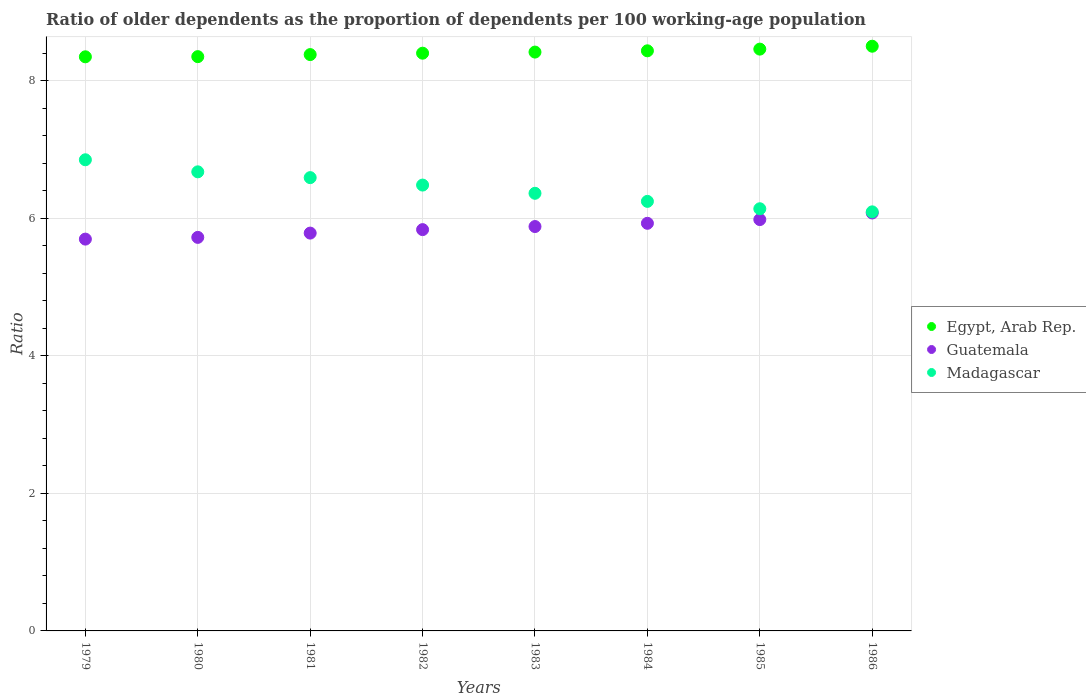How many different coloured dotlines are there?
Your answer should be very brief. 3. Is the number of dotlines equal to the number of legend labels?
Make the answer very short. Yes. What is the age dependency ratio(old) in Madagascar in 1984?
Ensure brevity in your answer.  6.24. Across all years, what is the maximum age dependency ratio(old) in Egypt, Arab Rep.?
Your answer should be compact. 8.5. Across all years, what is the minimum age dependency ratio(old) in Madagascar?
Offer a very short reply. 6.09. In which year was the age dependency ratio(old) in Guatemala maximum?
Give a very brief answer. 1986. In which year was the age dependency ratio(old) in Guatemala minimum?
Give a very brief answer. 1979. What is the total age dependency ratio(old) in Madagascar in the graph?
Offer a terse response. 51.43. What is the difference between the age dependency ratio(old) in Madagascar in 1979 and that in 1982?
Your answer should be very brief. 0.37. What is the difference between the age dependency ratio(old) in Egypt, Arab Rep. in 1986 and the age dependency ratio(old) in Madagascar in 1982?
Provide a short and direct response. 2.02. What is the average age dependency ratio(old) in Guatemala per year?
Your response must be concise. 5.86. In the year 1981, what is the difference between the age dependency ratio(old) in Egypt, Arab Rep. and age dependency ratio(old) in Madagascar?
Provide a short and direct response. 1.79. In how many years, is the age dependency ratio(old) in Madagascar greater than 2.4?
Provide a succinct answer. 8. What is the ratio of the age dependency ratio(old) in Madagascar in 1979 to that in 1980?
Your answer should be compact. 1.03. Is the difference between the age dependency ratio(old) in Egypt, Arab Rep. in 1982 and 1985 greater than the difference between the age dependency ratio(old) in Madagascar in 1982 and 1985?
Your answer should be very brief. No. What is the difference between the highest and the second highest age dependency ratio(old) in Guatemala?
Ensure brevity in your answer.  0.1. What is the difference between the highest and the lowest age dependency ratio(old) in Madagascar?
Offer a very short reply. 0.76. Is the sum of the age dependency ratio(old) in Madagascar in 1979 and 1982 greater than the maximum age dependency ratio(old) in Guatemala across all years?
Your answer should be compact. Yes. Is it the case that in every year, the sum of the age dependency ratio(old) in Guatemala and age dependency ratio(old) in Egypt, Arab Rep.  is greater than the age dependency ratio(old) in Madagascar?
Your response must be concise. Yes. Does the age dependency ratio(old) in Egypt, Arab Rep. monotonically increase over the years?
Your answer should be very brief. Yes. How many dotlines are there?
Give a very brief answer. 3. Does the graph contain any zero values?
Provide a short and direct response. No. Does the graph contain grids?
Offer a terse response. Yes. Where does the legend appear in the graph?
Your answer should be very brief. Center right. How many legend labels are there?
Your answer should be very brief. 3. What is the title of the graph?
Your answer should be compact. Ratio of older dependents as the proportion of dependents per 100 working-age population. What is the label or title of the Y-axis?
Your response must be concise. Ratio. What is the Ratio in Egypt, Arab Rep. in 1979?
Offer a very short reply. 8.35. What is the Ratio of Guatemala in 1979?
Provide a short and direct response. 5.7. What is the Ratio in Madagascar in 1979?
Your answer should be compact. 6.85. What is the Ratio in Egypt, Arab Rep. in 1980?
Your response must be concise. 8.35. What is the Ratio in Guatemala in 1980?
Keep it short and to the point. 5.72. What is the Ratio of Madagascar in 1980?
Offer a terse response. 6.67. What is the Ratio of Egypt, Arab Rep. in 1981?
Offer a terse response. 8.38. What is the Ratio of Guatemala in 1981?
Offer a very short reply. 5.78. What is the Ratio in Madagascar in 1981?
Your response must be concise. 6.59. What is the Ratio in Egypt, Arab Rep. in 1982?
Your response must be concise. 8.4. What is the Ratio of Guatemala in 1982?
Give a very brief answer. 5.83. What is the Ratio in Madagascar in 1982?
Your answer should be very brief. 6.48. What is the Ratio in Egypt, Arab Rep. in 1983?
Provide a short and direct response. 8.41. What is the Ratio in Guatemala in 1983?
Keep it short and to the point. 5.88. What is the Ratio of Madagascar in 1983?
Provide a short and direct response. 6.36. What is the Ratio in Egypt, Arab Rep. in 1984?
Your answer should be compact. 8.43. What is the Ratio in Guatemala in 1984?
Your response must be concise. 5.93. What is the Ratio of Madagascar in 1984?
Offer a terse response. 6.24. What is the Ratio of Egypt, Arab Rep. in 1985?
Your answer should be compact. 8.46. What is the Ratio in Guatemala in 1985?
Make the answer very short. 5.98. What is the Ratio of Madagascar in 1985?
Your answer should be compact. 6.14. What is the Ratio in Egypt, Arab Rep. in 1986?
Your answer should be very brief. 8.5. What is the Ratio in Guatemala in 1986?
Provide a succinct answer. 6.08. What is the Ratio of Madagascar in 1986?
Keep it short and to the point. 6.09. Across all years, what is the maximum Ratio of Egypt, Arab Rep.?
Give a very brief answer. 8.5. Across all years, what is the maximum Ratio of Guatemala?
Ensure brevity in your answer.  6.08. Across all years, what is the maximum Ratio of Madagascar?
Make the answer very short. 6.85. Across all years, what is the minimum Ratio in Egypt, Arab Rep.?
Give a very brief answer. 8.35. Across all years, what is the minimum Ratio in Guatemala?
Your answer should be compact. 5.7. Across all years, what is the minimum Ratio in Madagascar?
Make the answer very short. 6.09. What is the total Ratio in Egypt, Arab Rep. in the graph?
Offer a very short reply. 67.27. What is the total Ratio of Guatemala in the graph?
Keep it short and to the point. 46.89. What is the total Ratio of Madagascar in the graph?
Your answer should be compact. 51.43. What is the difference between the Ratio of Egypt, Arab Rep. in 1979 and that in 1980?
Offer a very short reply. -0. What is the difference between the Ratio in Guatemala in 1979 and that in 1980?
Your answer should be compact. -0.03. What is the difference between the Ratio in Madagascar in 1979 and that in 1980?
Give a very brief answer. 0.18. What is the difference between the Ratio of Egypt, Arab Rep. in 1979 and that in 1981?
Keep it short and to the point. -0.03. What is the difference between the Ratio of Guatemala in 1979 and that in 1981?
Ensure brevity in your answer.  -0.09. What is the difference between the Ratio in Madagascar in 1979 and that in 1981?
Your answer should be compact. 0.26. What is the difference between the Ratio in Egypt, Arab Rep. in 1979 and that in 1982?
Your answer should be compact. -0.05. What is the difference between the Ratio in Guatemala in 1979 and that in 1982?
Your response must be concise. -0.14. What is the difference between the Ratio of Madagascar in 1979 and that in 1982?
Make the answer very short. 0.37. What is the difference between the Ratio in Egypt, Arab Rep. in 1979 and that in 1983?
Give a very brief answer. -0.07. What is the difference between the Ratio of Guatemala in 1979 and that in 1983?
Offer a very short reply. -0.18. What is the difference between the Ratio of Madagascar in 1979 and that in 1983?
Your answer should be very brief. 0.49. What is the difference between the Ratio of Egypt, Arab Rep. in 1979 and that in 1984?
Provide a succinct answer. -0.09. What is the difference between the Ratio in Guatemala in 1979 and that in 1984?
Your answer should be very brief. -0.23. What is the difference between the Ratio of Madagascar in 1979 and that in 1984?
Your response must be concise. 0.6. What is the difference between the Ratio in Egypt, Arab Rep. in 1979 and that in 1985?
Make the answer very short. -0.11. What is the difference between the Ratio of Guatemala in 1979 and that in 1985?
Your response must be concise. -0.28. What is the difference between the Ratio of Madagascar in 1979 and that in 1985?
Give a very brief answer. 0.71. What is the difference between the Ratio in Egypt, Arab Rep. in 1979 and that in 1986?
Ensure brevity in your answer.  -0.15. What is the difference between the Ratio of Guatemala in 1979 and that in 1986?
Offer a terse response. -0.38. What is the difference between the Ratio of Madagascar in 1979 and that in 1986?
Give a very brief answer. 0.76. What is the difference between the Ratio in Egypt, Arab Rep. in 1980 and that in 1981?
Ensure brevity in your answer.  -0.03. What is the difference between the Ratio of Guatemala in 1980 and that in 1981?
Provide a short and direct response. -0.06. What is the difference between the Ratio of Madagascar in 1980 and that in 1981?
Ensure brevity in your answer.  0.08. What is the difference between the Ratio in Egypt, Arab Rep. in 1980 and that in 1982?
Make the answer very short. -0.05. What is the difference between the Ratio in Guatemala in 1980 and that in 1982?
Your response must be concise. -0.11. What is the difference between the Ratio in Madagascar in 1980 and that in 1982?
Make the answer very short. 0.19. What is the difference between the Ratio in Egypt, Arab Rep. in 1980 and that in 1983?
Offer a very short reply. -0.07. What is the difference between the Ratio of Guatemala in 1980 and that in 1983?
Offer a terse response. -0.16. What is the difference between the Ratio in Madagascar in 1980 and that in 1983?
Provide a succinct answer. 0.31. What is the difference between the Ratio in Egypt, Arab Rep. in 1980 and that in 1984?
Provide a short and direct response. -0.08. What is the difference between the Ratio of Guatemala in 1980 and that in 1984?
Give a very brief answer. -0.2. What is the difference between the Ratio of Madagascar in 1980 and that in 1984?
Your answer should be compact. 0.43. What is the difference between the Ratio in Egypt, Arab Rep. in 1980 and that in 1985?
Offer a terse response. -0.11. What is the difference between the Ratio in Guatemala in 1980 and that in 1985?
Provide a succinct answer. -0.26. What is the difference between the Ratio of Madagascar in 1980 and that in 1985?
Your answer should be very brief. 0.54. What is the difference between the Ratio of Egypt, Arab Rep. in 1980 and that in 1986?
Ensure brevity in your answer.  -0.15. What is the difference between the Ratio in Guatemala in 1980 and that in 1986?
Provide a short and direct response. -0.35. What is the difference between the Ratio of Madagascar in 1980 and that in 1986?
Provide a short and direct response. 0.58. What is the difference between the Ratio in Egypt, Arab Rep. in 1981 and that in 1982?
Your answer should be compact. -0.02. What is the difference between the Ratio in Guatemala in 1981 and that in 1982?
Give a very brief answer. -0.05. What is the difference between the Ratio in Madagascar in 1981 and that in 1982?
Offer a very short reply. 0.11. What is the difference between the Ratio in Egypt, Arab Rep. in 1981 and that in 1983?
Offer a very short reply. -0.04. What is the difference between the Ratio in Guatemala in 1981 and that in 1983?
Keep it short and to the point. -0.1. What is the difference between the Ratio in Madagascar in 1981 and that in 1983?
Ensure brevity in your answer.  0.23. What is the difference between the Ratio of Egypt, Arab Rep. in 1981 and that in 1984?
Ensure brevity in your answer.  -0.05. What is the difference between the Ratio of Guatemala in 1981 and that in 1984?
Your answer should be very brief. -0.14. What is the difference between the Ratio in Madagascar in 1981 and that in 1984?
Offer a terse response. 0.35. What is the difference between the Ratio in Egypt, Arab Rep. in 1981 and that in 1985?
Offer a very short reply. -0.08. What is the difference between the Ratio of Guatemala in 1981 and that in 1985?
Offer a terse response. -0.2. What is the difference between the Ratio in Madagascar in 1981 and that in 1985?
Give a very brief answer. 0.45. What is the difference between the Ratio of Egypt, Arab Rep. in 1981 and that in 1986?
Provide a succinct answer. -0.12. What is the difference between the Ratio of Guatemala in 1981 and that in 1986?
Provide a succinct answer. -0.29. What is the difference between the Ratio of Madagascar in 1981 and that in 1986?
Ensure brevity in your answer.  0.5. What is the difference between the Ratio of Egypt, Arab Rep. in 1982 and that in 1983?
Give a very brief answer. -0.02. What is the difference between the Ratio of Guatemala in 1982 and that in 1983?
Provide a short and direct response. -0.04. What is the difference between the Ratio in Madagascar in 1982 and that in 1983?
Offer a very short reply. 0.12. What is the difference between the Ratio of Egypt, Arab Rep. in 1982 and that in 1984?
Keep it short and to the point. -0.03. What is the difference between the Ratio in Guatemala in 1982 and that in 1984?
Provide a succinct answer. -0.09. What is the difference between the Ratio in Madagascar in 1982 and that in 1984?
Provide a succinct answer. 0.24. What is the difference between the Ratio in Egypt, Arab Rep. in 1982 and that in 1985?
Provide a short and direct response. -0.06. What is the difference between the Ratio in Guatemala in 1982 and that in 1985?
Your answer should be very brief. -0.15. What is the difference between the Ratio in Madagascar in 1982 and that in 1985?
Your answer should be very brief. 0.34. What is the difference between the Ratio of Egypt, Arab Rep. in 1982 and that in 1986?
Ensure brevity in your answer.  -0.1. What is the difference between the Ratio in Guatemala in 1982 and that in 1986?
Ensure brevity in your answer.  -0.24. What is the difference between the Ratio of Madagascar in 1982 and that in 1986?
Your response must be concise. 0.39. What is the difference between the Ratio in Egypt, Arab Rep. in 1983 and that in 1984?
Make the answer very short. -0.02. What is the difference between the Ratio in Guatemala in 1983 and that in 1984?
Keep it short and to the point. -0.05. What is the difference between the Ratio of Madagascar in 1983 and that in 1984?
Your answer should be compact. 0.12. What is the difference between the Ratio of Egypt, Arab Rep. in 1983 and that in 1985?
Give a very brief answer. -0.04. What is the difference between the Ratio in Guatemala in 1983 and that in 1985?
Your answer should be compact. -0.1. What is the difference between the Ratio in Madagascar in 1983 and that in 1985?
Your answer should be compact. 0.22. What is the difference between the Ratio in Egypt, Arab Rep. in 1983 and that in 1986?
Your response must be concise. -0.09. What is the difference between the Ratio of Guatemala in 1983 and that in 1986?
Your answer should be compact. -0.2. What is the difference between the Ratio in Madagascar in 1983 and that in 1986?
Ensure brevity in your answer.  0.27. What is the difference between the Ratio of Egypt, Arab Rep. in 1984 and that in 1985?
Your answer should be very brief. -0.02. What is the difference between the Ratio in Guatemala in 1984 and that in 1985?
Provide a short and direct response. -0.05. What is the difference between the Ratio of Madagascar in 1984 and that in 1985?
Offer a terse response. 0.11. What is the difference between the Ratio of Egypt, Arab Rep. in 1984 and that in 1986?
Provide a short and direct response. -0.07. What is the difference between the Ratio in Guatemala in 1984 and that in 1986?
Your response must be concise. -0.15. What is the difference between the Ratio in Madagascar in 1984 and that in 1986?
Give a very brief answer. 0.15. What is the difference between the Ratio of Egypt, Arab Rep. in 1985 and that in 1986?
Make the answer very short. -0.04. What is the difference between the Ratio of Guatemala in 1985 and that in 1986?
Offer a terse response. -0.1. What is the difference between the Ratio in Madagascar in 1985 and that in 1986?
Your answer should be compact. 0.04. What is the difference between the Ratio of Egypt, Arab Rep. in 1979 and the Ratio of Guatemala in 1980?
Offer a terse response. 2.62. What is the difference between the Ratio of Egypt, Arab Rep. in 1979 and the Ratio of Madagascar in 1980?
Keep it short and to the point. 1.67. What is the difference between the Ratio of Guatemala in 1979 and the Ratio of Madagascar in 1980?
Your answer should be very brief. -0.98. What is the difference between the Ratio in Egypt, Arab Rep. in 1979 and the Ratio in Guatemala in 1981?
Ensure brevity in your answer.  2.56. What is the difference between the Ratio of Egypt, Arab Rep. in 1979 and the Ratio of Madagascar in 1981?
Your answer should be very brief. 1.76. What is the difference between the Ratio in Guatemala in 1979 and the Ratio in Madagascar in 1981?
Provide a succinct answer. -0.89. What is the difference between the Ratio of Egypt, Arab Rep. in 1979 and the Ratio of Guatemala in 1982?
Keep it short and to the point. 2.51. What is the difference between the Ratio of Egypt, Arab Rep. in 1979 and the Ratio of Madagascar in 1982?
Ensure brevity in your answer.  1.86. What is the difference between the Ratio in Guatemala in 1979 and the Ratio in Madagascar in 1982?
Make the answer very short. -0.79. What is the difference between the Ratio of Egypt, Arab Rep. in 1979 and the Ratio of Guatemala in 1983?
Offer a terse response. 2.47. What is the difference between the Ratio in Egypt, Arab Rep. in 1979 and the Ratio in Madagascar in 1983?
Make the answer very short. 1.98. What is the difference between the Ratio in Guatemala in 1979 and the Ratio in Madagascar in 1983?
Provide a short and direct response. -0.67. What is the difference between the Ratio in Egypt, Arab Rep. in 1979 and the Ratio in Guatemala in 1984?
Your answer should be very brief. 2.42. What is the difference between the Ratio in Egypt, Arab Rep. in 1979 and the Ratio in Madagascar in 1984?
Offer a terse response. 2.1. What is the difference between the Ratio of Guatemala in 1979 and the Ratio of Madagascar in 1984?
Your answer should be compact. -0.55. What is the difference between the Ratio of Egypt, Arab Rep. in 1979 and the Ratio of Guatemala in 1985?
Provide a short and direct response. 2.37. What is the difference between the Ratio in Egypt, Arab Rep. in 1979 and the Ratio in Madagascar in 1985?
Your response must be concise. 2.21. What is the difference between the Ratio in Guatemala in 1979 and the Ratio in Madagascar in 1985?
Make the answer very short. -0.44. What is the difference between the Ratio in Egypt, Arab Rep. in 1979 and the Ratio in Guatemala in 1986?
Provide a short and direct response. 2.27. What is the difference between the Ratio of Egypt, Arab Rep. in 1979 and the Ratio of Madagascar in 1986?
Offer a terse response. 2.25. What is the difference between the Ratio of Guatemala in 1979 and the Ratio of Madagascar in 1986?
Offer a terse response. -0.4. What is the difference between the Ratio of Egypt, Arab Rep. in 1980 and the Ratio of Guatemala in 1981?
Your answer should be compact. 2.56. What is the difference between the Ratio of Egypt, Arab Rep. in 1980 and the Ratio of Madagascar in 1981?
Offer a very short reply. 1.76. What is the difference between the Ratio in Guatemala in 1980 and the Ratio in Madagascar in 1981?
Keep it short and to the point. -0.87. What is the difference between the Ratio of Egypt, Arab Rep. in 1980 and the Ratio of Guatemala in 1982?
Provide a short and direct response. 2.51. What is the difference between the Ratio of Egypt, Arab Rep. in 1980 and the Ratio of Madagascar in 1982?
Your answer should be compact. 1.87. What is the difference between the Ratio of Guatemala in 1980 and the Ratio of Madagascar in 1982?
Your response must be concise. -0.76. What is the difference between the Ratio in Egypt, Arab Rep. in 1980 and the Ratio in Guatemala in 1983?
Give a very brief answer. 2.47. What is the difference between the Ratio of Egypt, Arab Rep. in 1980 and the Ratio of Madagascar in 1983?
Provide a short and direct response. 1.99. What is the difference between the Ratio of Guatemala in 1980 and the Ratio of Madagascar in 1983?
Offer a terse response. -0.64. What is the difference between the Ratio in Egypt, Arab Rep. in 1980 and the Ratio in Guatemala in 1984?
Ensure brevity in your answer.  2.42. What is the difference between the Ratio of Egypt, Arab Rep. in 1980 and the Ratio of Madagascar in 1984?
Provide a short and direct response. 2.1. What is the difference between the Ratio of Guatemala in 1980 and the Ratio of Madagascar in 1984?
Ensure brevity in your answer.  -0.52. What is the difference between the Ratio of Egypt, Arab Rep. in 1980 and the Ratio of Guatemala in 1985?
Give a very brief answer. 2.37. What is the difference between the Ratio of Egypt, Arab Rep. in 1980 and the Ratio of Madagascar in 1985?
Your response must be concise. 2.21. What is the difference between the Ratio in Guatemala in 1980 and the Ratio in Madagascar in 1985?
Offer a terse response. -0.42. What is the difference between the Ratio in Egypt, Arab Rep. in 1980 and the Ratio in Guatemala in 1986?
Keep it short and to the point. 2.27. What is the difference between the Ratio of Egypt, Arab Rep. in 1980 and the Ratio of Madagascar in 1986?
Make the answer very short. 2.26. What is the difference between the Ratio in Guatemala in 1980 and the Ratio in Madagascar in 1986?
Make the answer very short. -0.37. What is the difference between the Ratio in Egypt, Arab Rep. in 1981 and the Ratio in Guatemala in 1982?
Your answer should be very brief. 2.54. What is the difference between the Ratio in Egypt, Arab Rep. in 1981 and the Ratio in Madagascar in 1982?
Provide a short and direct response. 1.9. What is the difference between the Ratio of Guatemala in 1981 and the Ratio of Madagascar in 1982?
Your response must be concise. -0.7. What is the difference between the Ratio in Egypt, Arab Rep. in 1981 and the Ratio in Guatemala in 1983?
Offer a terse response. 2.5. What is the difference between the Ratio in Egypt, Arab Rep. in 1981 and the Ratio in Madagascar in 1983?
Keep it short and to the point. 2.02. What is the difference between the Ratio of Guatemala in 1981 and the Ratio of Madagascar in 1983?
Provide a succinct answer. -0.58. What is the difference between the Ratio of Egypt, Arab Rep. in 1981 and the Ratio of Guatemala in 1984?
Keep it short and to the point. 2.45. What is the difference between the Ratio of Egypt, Arab Rep. in 1981 and the Ratio of Madagascar in 1984?
Provide a succinct answer. 2.13. What is the difference between the Ratio in Guatemala in 1981 and the Ratio in Madagascar in 1984?
Offer a terse response. -0.46. What is the difference between the Ratio in Egypt, Arab Rep. in 1981 and the Ratio in Guatemala in 1985?
Your response must be concise. 2.4. What is the difference between the Ratio in Egypt, Arab Rep. in 1981 and the Ratio in Madagascar in 1985?
Give a very brief answer. 2.24. What is the difference between the Ratio of Guatemala in 1981 and the Ratio of Madagascar in 1985?
Offer a terse response. -0.35. What is the difference between the Ratio of Egypt, Arab Rep. in 1981 and the Ratio of Guatemala in 1986?
Provide a short and direct response. 2.3. What is the difference between the Ratio in Egypt, Arab Rep. in 1981 and the Ratio in Madagascar in 1986?
Your answer should be compact. 2.29. What is the difference between the Ratio of Guatemala in 1981 and the Ratio of Madagascar in 1986?
Your response must be concise. -0.31. What is the difference between the Ratio in Egypt, Arab Rep. in 1982 and the Ratio in Guatemala in 1983?
Offer a very short reply. 2.52. What is the difference between the Ratio of Egypt, Arab Rep. in 1982 and the Ratio of Madagascar in 1983?
Provide a succinct answer. 2.04. What is the difference between the Ratio in Guatemala in 1982 and the Ratio in Madagascar in 1983?
Provide a succinct answer. -0.53. What is the difference between the Ratio of Egypt, Arab Rep. in 1982 and the Ratio of Guatemala in 1984?
Offer a terse response. 2.47. What is the difference between the Ratio in Egypt, Arab Rep. in 1982 and the Ratio in Madagascar in 1984?
Keep it short and to the point. 2.15. What is the difference between the Ratio of Guatemala in 1982 and the Ratio of Madagascar in 1984?
Provide a short and direct response. -0.41. What is the difference between the Ratio of Egypt, Arab Rep. in 1982 and the Ratio of Guatemala in 1985?
Your answer should be very brief. 2.42. What is the difference between the Ratio of Egypt, Arab Rep. in 1982 and the Ratio of Madagascar in 1985?
Provide a succinct answer. 2.26. What is the difference between the Ratio of Guatemala in 1982 and the Ratio of Madagascar in 1985?
Offer a very short reply. -0.3. What is the difference between the Ratio of Egypt, Arab Rep. in 1982 and the Ratio of Guatemala in 1986?
Your response must be concise. 2.32. What is the difference between the Ratio in Egypt, Arab Rep. in 1982 and the Ratio in Madagascar in 1986?
Your answer should be very brief. 2.31. What is the difference between the Ratio of Guatemala in 1982 and the Ratio of Madagascar in 1986?
Your answer should be compact. -0.26. What is the difference between the Ratio of Egypt, Arab Rep. in 1983 and the Ratio of Guatemala in 1984?
Your answer should be compact. 2.49. What is the difference between the Ratio of Egypt, Arab Rep. in 1983 and the Ratio of Madagascar in 1984?
Offer a very short reply. 2.17. What is the difference between the Ratio in Guatemala in 1983 and the Ratio in Madagascar in 1984?
Ensure brevity in your answer.  -0.37. What is the difference between the Ratio in Egypt, Arab Rep. in 1983 and the Ratio in Guatemala in 1985?
Offer a very short reply. 2.43. What is the difference between the Ratio in Egypt, Arab Rep. in 1983 and the Ratio in Madagascar in 1985?
Your answer should be very brief. 2.28. What is the difference between the Ratio of Guatemala in 1983 and the Ratio of Madagascar in 1985?
Give a very brief answer. -0.26. What is the difference between the Ratio in Egypt, Arab Rep. in 1983 and the Ratio in Guatemala in 1986?
Give a very brief answer. 2.34. What is the difference between the Ratio in Egypt, Arab Rep. in 1983 and the Ratio in Madagascar in 1986?
Offer a very short reply. 2.32. What is the difference between the Ratio in Guatemala in 1983 and the Ratio in Madagascar in 1986?
Your answer should be compact. -0.21. What is the difference between the Ratio of Egypt, Arab Rep. in 1984 and the Ratio of Guatemala in 1985?
Provide a succinct answer. 2.45. What is the difference between the Ratio in Egypt, Arab Rep. in 1984 and the Ratio in Madagascar in 1985?
Provide a succinct answer. 2.3. What is the difference between the Ratio in Guatemala in 1984 and the Ratio in Madagascar in 1985?
Make the answer very short. -0.21. What is the difference between the Ratio in Egypt, Arab Rep. in 1984 and the Ratio in Guatemala in 1986?
Offer a terse response. 2.36. What is the difference between the Ratio of Egypt, Arab Rep. in 1984 and the Ratio of Madagascar in 1986?
Give a very brief answer. 2.34. What is the difference between the Ratio in Guatemala in 1984 and the Ratio in Madagascar in 1986?
Provide a short and direct response. -0.17. What is the difference between the Ratio of Egypt, Arab Rep. in 1985 and the Ratio of Guatemala in 1986?
Ensure brevity in your answer.  2.38. What is the difference between the Ratio of Egypt, Arab Rep. in 1985 and the Ratio of Madagascar in 1986?
Offer a terse response. 2.37. What is the difference between the Ratio of Guatemala in 1985 and the Ratio of Madagascar in 1986?
Keep it short and to the point. -0.11. What is the average Ratio in Egypt, Arab Rep. per year?
Your answer should be very brief. 8.41. What is the average Ratio of Guatemala per year?
Provide a succinct answer. 5.86. What is the average Ratio of Madagascar per year?
Offer a very short reply. 6.43. In the year 1979, what is the difference between the Ratio of Egypt, Arab Rep. and Ratio of Guatemala?
Your answer should be very brief. 2.65. In the year 1979, what is the difference between the Ratio of Egypt, Arab Rep. and Ratio of Madagascar?
Your answer should be very brief. 1.5. In the year 1979, what is the difference between the Ratio in Guatemala and Ratio in Madagascar?
Keep it short and to the point. -1.15. In the year 1980, what is the difference between the Ratio in Egypt, Arab Rep. and Ratio in Guatemala?
Keep it short and to the point. 2.63. In the year 1980, what is the difference between the Ratio of Egypt, Arab Rep. and Ratio of Madagascar?
Provide a short and direct response. 1.67. In the year 1980, what is the difference between the Ratio of Guatemala and Ratio of Madagascar?
Offer a very short reply. -0.95. In the year 1981, what is the difference between the Ratio in Egypt, Arab Rep. and Ratio in Guatemala?
Your answer should be very brief. 2.6. In the year 1981, what is the difference between the Ratio in Egypt, Arab Rep. and Ratio in Madagascar?
Give a very brief answer. 1.79. In the year 1981, what is the difference between the Ratio of Guatemala and Ratio of Madagascar?
Provide a succinct answer. -0.81. In the year 1982, what is the difference between the Ratio of Egypt, Arab Rep. and Ratio of Guatemala?
Give a very brief answer. 2.56. In the year 1982, what is the difference between the Ratio in Egypt, Arab Rep. and Ratio in Madagascar?
Give a very brief answer. 1.92. In the year 1982, what is the difference between the Ratio of Guatemala and Ratio of Madagascar?
Provide a short and direct response. -0.65. In the year 1983, what is the difference between the Ratio in Egypt, Arab Rep. and Ratio in Guatemala?
Your answer should be compact. 2.54. In the year 1983, what is the difference between the Ratio of Egypt, Arab Rep. and Ratio of Madagascar?
Your answer should be very brief. 2.05. In the year 1983, what is the difference between the Ratio in Guatemala and Ratio in Madagascar?
Provide a short and direct response. -0.48. In the year 1984, what is the difference between the Ratio of Egypt, Arab Rep. and Ratio of Guatemala?
Provide a succinct answer. 2.51. In the year 1984, what is the difference between the Ratio in Egypt, Arab Rep. and Ratio in Madagascar?
Provide a short and direct response. 2.19. In the year 1984, what is the difference between the Ratio in Guatemala and Ratio in Madagascar?
Provide a succinct answer. -0.32. In the year 1985, what is the difference between the Ratio of Egypt, Arab Rep. and Ratio of Guatemala?
Provide a short and direct response. 2.48. In the year 1985, what is the difference between the Ratio in Egypt, Arab Rep. and Ratio in Madagascar?
Offer a very short reply. 2.32. In the year 1985, what is the difference between the Ratio in Guatemala and Ratio in Madagascar?
Ensure brevity in your answer.  -0.16. In the year 1986, what is the difference between the Ratio of Egypt, Arab Rep. and Ratio of Guatemala?
Give a very brief answer. 2.42. In the year 1986, what is the difference between the Ratio in Egypt, Arab Rep. and Ratio in Madagascar?
Your answer should be very brief. 2.41. In the year 1986, what is the difference between the Ratio of Guatemala and Ratio of Madagascar?
Give a very brief answer. -0.02. What is the ratio of the Ratio in Guatemala in 1979 to that in 1980?
Your answer should be very brief. 1. What is the ratio of the Ratio in Madagascar in 1979 to that in 1980?
Give a very brief answer. 1.03. What is the ratio of the Ratio in Egypt, Arab Rep. in 1979 to that in 1981?
Keep it short and to the point. 1. What is the ratio of the Ratio in Guatemala in 1979 to that in 1981?
Keep it short and to the point. 0.98. What is the ratio of the Ratio of Madagascar in 1979 to that in 1981?
Your answer should be very brief. 1.04. What is the ratio of the Ratio in Egypt, Arab Rep. in 1979 to that in 1982?
Give a very brief answer. 0.99. What is the ratio of the Ratio in Guatemala in 1979 to that in 1982?
Provide a succinct answer. 0.98. What is the ratio of the Ratio in Madagascar in 1979 to that in 1982?
Your response must be concise. 1.06. What is the ratio of the Ratio in Egypt, Arab Rep. in 1979 to that in 1983?
Your answer should be very brief. 0.99. What is the ratio of the Ratio in Guatemala in 1979 to that in 1983?
Your response must be concise. 0.97. What is the ratio of the Ratio in Madagascar in 1979 to that in 1983?
Your answer should be compact. 1.08. What is the ratio of the Ratio in Guatemala in 1979 to that in 1984?
Provide a succinct answer. 0.96. What is the ratio of the Ratio in Madagascar in 1979 to that in 1984?
Make the answer very short. 1.1. What is the ratio of the Ratio in Egypt, Arab Rep. in 1979 to that in 1985?
Provide a succinct answer. 0.99. What is the ratio of the Ratio in Guatemala in 1979 to that in 1985?
Your answer should be compact. 0.95. What is the ratio of the Ratio in Madagascar in 1979 to that in 1985?
Offer a terse response. 1.12. What is the ratio of the Ratio in Egypt, Arab Rep. in 1979 to that in 1986?
Offer a very short reply. 0.98. What is the ratio of the Ratio of Madagascar in 1979 to that in 1986?
Ensure brevity in your answer.  1.12. What is the ratio of the Ratio of Egypt, Arab Rep. in 1980 to that in 1981?
Offer a terse response. 1. What is the ratio of the Ratio in Guatemala in 1980 to that in 1981?
Your answer should be very brief. 0.99. What is the ratio of the Ratio in Madagascar in 1980 to that in 1981?
Ensure brevity in your answer.  1.01. What is the ratio of the Ratio in Egypt, Arab Rep. in 1980 to that in 1982?
Offer a terse response. 0.99. What is the ratio of the Ratio in Guatemala in 1980 to that in 1982?
Offer a terse response. 0.98. What is the ratio of the Ratio of Madagascar in 1980 to that in 1982?
Your response must be concise. 1.03. What is the ratio of the Ratio of Guatemala in 1980 to that in 1983?
Your answer should be very brief. 0.97. What is the ratio of the Ratio in Madagascar in 1980 to that in 1983?
Provide a short and direct response. 1.05. What is the ratio of the Ratio of Egypt, Arab Rep. in 1980 to that in 1984?
Make the answer very short. 0.99. What is the ratio of the Ratio in Guatemala in 1980 to that in 1984?
Offer a very short reply. 0.97. What is the ratio of the Ratio of Madagascar in 1980 to that in 1984?
Give a very brief answer. 1.07. What is the ratio of the Ratio of Egypt, Arab Rep. in 1980 to that in 1985?
Ensure brevity in your answer.  0.99. What is the ratio of the Ratio in Guatemala in 1980 to that in 1985?
Your answer should be compact. 0.96. What is the ratio of the Ratio of Madagascar in 1980 to that in 1985?
Provide a succinct answer. 1.09. What is the ratio of the Ratio in Egypt, Arab Rep. in 1980 to that in 1986?
Make the answer very short. 0.98. What is the ratio of the Ratio in Guatemala in 1980 to that in 1986?
Ensure brevity in your answer.  0.94. What is the ratio of the Ratio in Madagascar in 1980 to that in 1986?
Keep it short and to the point. 1.1. What is the ratio of the Ratio of Guatemala in 1981 to that in 1982?
Your answer should be very brief. 0.99. What is the ratio of the Ratio of Madagascar in 1981 to that in 1982?
Provide a succinct answer. 1.02. What is the ratio of the Ratio of Egypt, Arab Rep. in 1981 to that in 1983?
Your response must be concise. 1. What is the ratio of the Ratio of Guatemala in 1981 to that in 1983?
Provide a succinct answer. 0.98. What is the ratio of the Ratio in Madagascar in 1981 to that in 1983?
Provide a succinct answer. 1.04. What is the ratio of the Ratio of Madagascar in 1981 to that in 1984?
Keep it short and to the point. 1.06. What is the ratio of the Ratio in Egypt, Arab Rep. in 1981 to that in 1985?
Your answer should be very brief. 0.99. What is the ratio of the Ratio of Guatemala in 1981 to that in 1985?
Ensure brevity in your answer.  0.97. What is the ratio of the Ratio of Madagascar in 1981 to that in 1985?
Make the answer very short. 1.07. What is the ratio of the Ratio in Egypt, Arab Rep. in 1981 to that in 1986?
Make the answer very short. 0.99. What is the ratio of the Ratio of Guatemala in 1981 to that in 1986?
Ensure brevity in your answer.  0.95. What is the ratio of the Ratio of Madagascar in 1981 to that in 1986?
Make the answer very short. 1.08. What is the ratio of the Ratio in Guatemala in 1982 to that in 1983?
Keep it short and to the point. 0.99. What is the ratio of the Ratio in Madagascar in 1982 to that in 1983?
Give a very brief answer. 1.02. What is the ratio of the Ratio in Egypt, Arab Rep. in 1982 to that in 1984?
Your answer should be compact. 1. What is the ratio of the Ratio of Guatemala in 1982 to that in 1984?
Your answer should be compact. 0.98. What is the ratio of the Ratio in Madagascar in 1982 to that in 1984?
Provide a short and direct response. 1.04. What is the ratio of the Ratio of Egypt, Arab Rep. in 1982 to that in 1985?
Keep it short and to the point. 0.99. What is the ratio of the Ratio in Guatemala in 1982 to that in 1985?
Your answer should be very brief. 0.98. What is the ratio of the Ratio in Madagascar in 1982 to that in 1985?
Your response must be concise. 1.06. What is the ratio of the Ratio of Egypt, Arab Rep. in 1982 to that in 1986?
Provide a succinct answer. 0.99. What is the ratio of the Ratio in Guatemala in 1982 to that in 1986?
Make the answer very short. 0.96. What is the ratio of the Ratio of Madagascar in 1982 to that in 1986?
Make the answer very short. 1.06. What is the ratio of the Ratio in Madagascar in 1983 to that in 1984?
Keep it short and to the point. 1.02. What is the ratio of the Ratio of Egypt, Arab Rep. in 1983 to that in 1985?
Give a very brief answer. 0.99. What is the ratio of the Ratio in Guatemala in 1983 to that in 1985?
Your answer should be very brief. 0.98. What is the ratio of the Ratio in Madagascar in 1983 to that in 1985?
Make the answer very short. 1.04. What is the ratio of the Ratio in Egypt, Arab Rep. in 1983 to that in 1986?
Offer a terse response. 0.99. What is the ratio of the Ratio of Guatemala in 1983 to that in 1986?
Keep it short and to the point. 0.97. What is the ratio of the Ratio in Madagascar in 1983 to that in 1986?
Give a very brief answer. 1.04. What is the ratio of the Ratio of Egypt, Arab Rep. in 1984 to that in 1985?
Provide a short and direct response. 1. What is the ratio of the Ratio in Guatemala in 1984 to that in 1985?
Ensure brevity in your answer.  0.99. What is the ratio of the Ratio of Madagascar in 1984 to that in 1985?
Offer a very short reply. 1.02. What is the ratio of the Ratio in Guatemala in 1984 to that in 1986?
Provide a succinct answer. 0.98. What is the ratio of the Ratio in Madagascar in 1984 to that in 1986?
Provide a succinct answer. 1.02. What is the ratio of the Ratio of Guatemala in 1985 to that in 1986?
Your answer should be very brief. 0.98. What is the ratio of the Ratio in Madagascar in 1985 to that in 1986?
Your answer should be compact. 1.01. What is the difference between the highest and the second highest Ratio of Egypt, Arab Rep.?
Provide a succinct answer. 0.04. What is the difference between the highest and the second highest Ratio in Guatemala?
Ensure brevity in your answer.  0.1. What is the difference between the highest and the second highest Ratio of Madagascar?
Keep it short and to the point. 0.18. What is the difference between the highest and the lowest Ratio in Egypt, Arab Rep.?
Your answer should be compact. 0.15. What is the difference between the highest and the lowest Ratio of Guatemala?
Ensure brevity in your answer.  0.38. What is the difference between the highest and the lowest Ratio of Madagascar?
Your response must be concise. 0.76. 